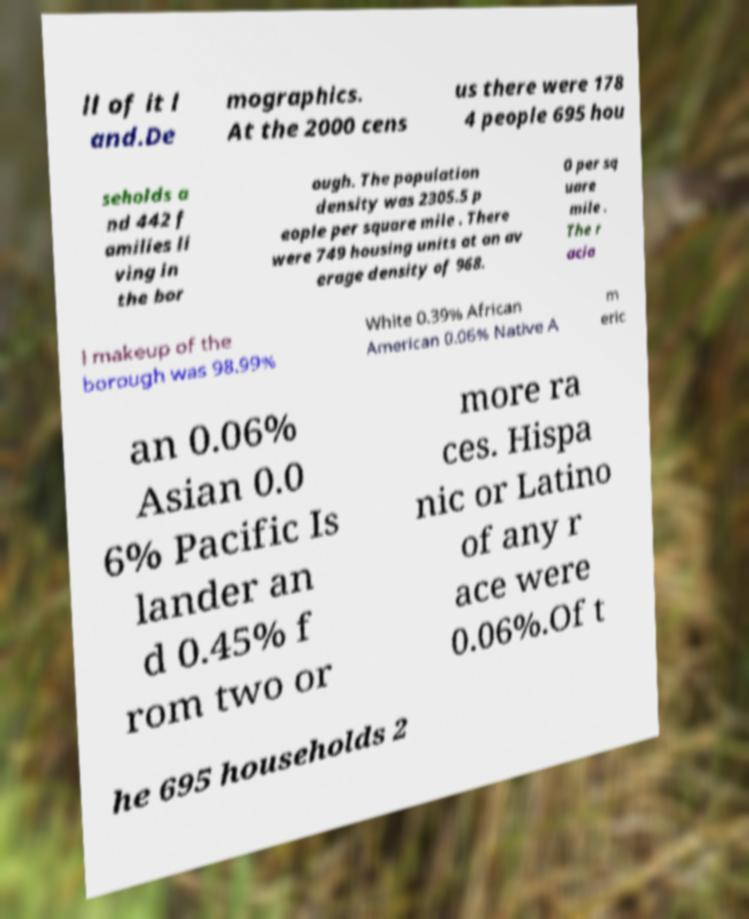Can you read and provide the text displayed in the image?This photo seems to have some interesting text. Can you extract and type it out for me? ll of it l and.De mographics. At the 2000 cens us there were 178 4 people 695 hou seholds a nd 442 f amilies li ving in the bor ough. The population density was 2305.5 p eople per square mile . There were 749 housing units at an av erage density of 968. 0 per sq uare mile . The r acia l makeup of the borough was 98.99% White 0.39% African American 0.06% Native A m eric an 0.06% Asian 0.0 6% Pacific Is lander an d 0.45% f rom two or more ra ces. Hispa nic or Latino of any r ace were 0.06%.Of t he 695 households 2 